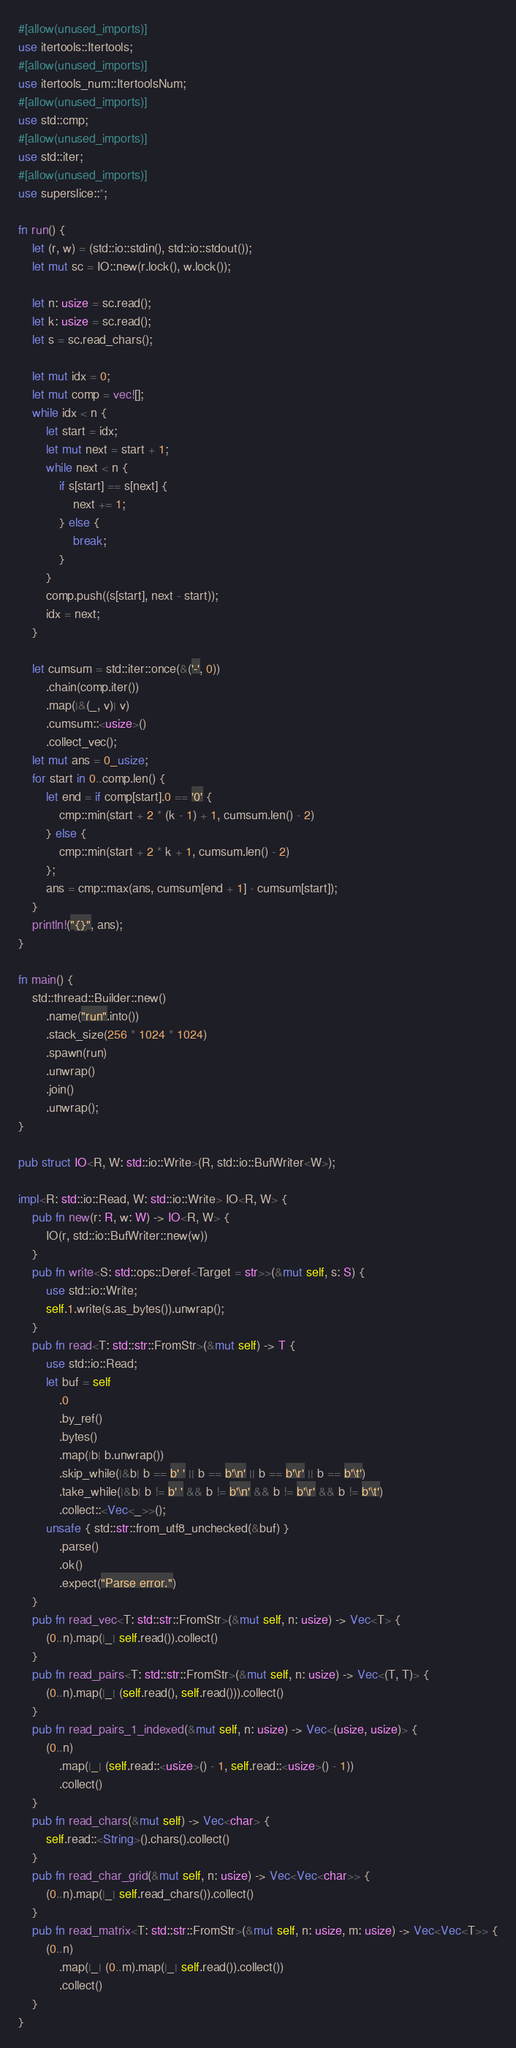<code> <loc_0><loc_0><loc_500><loc_500><_Rust_>#[allow(unused_imports)]
use itertools::Itertools;
#[allow(unused_imports)]
use itertools_num::ItertoolsNum;
#[allow(unused_imports)]
use std::cmp;
#[allow(unused_imports)]
use std::iter;
#[allow(unused_imports)]
use superslice::*;

fn run() {
    let (r, w) = (std::io::stdin(), std::io::stdout());
    let mut sc = IO::new(r.lock(), w.lock());

    let n: usize = sc.read();
    let k: usize = sc.read();
    let s = sc.read_chars();

    let mut idx = 0;
    let mut comp = vec![];
    while idx < n {
        let start = idx;
        let mut next = start + 1;
        while next < n {
            if s[start] == s[next] {
                next += 1;
            } else {
                break;
            }
        }
        comp.push((s[start], next - start));
        idx = next;
    }

    let cumsum = std::iter::once(&('-', 0))
        .chain(comp.iter())
        .map(|&(_, v)| v)
        .cumsum::<usize>()
        .collect_vec();
    let mut ans = 0_usize;
    for start in 0..comp.len() {
        let end = if comp[start].0 == '0' {
            cmp::min(start + 2 * (k - 1) + 1, cumsum.len() - 2)
        } else {
            cmp::min(start + 2 * k + 1, cumsum.len() - 2)
        };
        ans = cmp::max(ans, cumsum[end + 1] - cumsum[start]);
    }
    println!("{}", ans);
}

fn main() {
    std::thread::Builder::new()
        .name("run".into())
        .stack_size(256 * 1024 * 1024)
        .spawn(run)
        .unwrap()
        .join()
        .unwrap();
}

pub struct IO<R, W: std::io::Write>(R, std::io::BufWriter<W>);

impl<R: std::io::Read, W: std::io::Write> IO<R, W> {
    pub fn new(r: R, w: W) -> IO<R, W> {
        IO(r, std::io::BufWriter::new(w))
    }
    pub fn write<S: std::ops::Deref<Target = str>>(&mut self, s: S) {
        use std::io::Write;
        self.1.write(s.as_bytes()).unwrap();
    }
    pub fn read<T: std::str::FromStr>(&mut self) -> T {
        use std::io::Read;
        let buf = self
            .0
            .by_ref()
            .bytes()
            .map(|b| b.unwrap())
            .skip_while(|&b| b == b' ' || b == b'\n' || b == b'\r' || b == b'\t')
            .take_while(|&b| b != b' ' && b != b'\n' && b != b'\r' && b != b'\t')
            .collect::<Vec<_>>();
        unsafe { std::str::from_utf8_unchecked(&buf) }
            .parse()
            .ok()
            .expect("Parse error.")
    }
    pub fn read_vec<T: std::str::FromStr>(&mut self, n: usize) -> Vec<T> {
        (0..n).map(|_| self.read()).collect()
    }
    pub fn read_pairs<T: std::str::FromStr>(&mut self, n: usize) -> Vec<(T, T)> {
        (0..n).map(|_| (self.read(), self.read())).collect()
    }
    pub fn read_pairs_1_indexed(&mut self, n: usize) -> Vec<(usize, usize)> {
        (0..n)
            .map(|_| (self.read::<usize>() - 1, self.read::<usize>() - 1))
            .collect()
    }
    pub fn read_chars(&mut self) -> Vec<char> {
        self.read::<String>().chars().collect()
    }
    pub fn read_char_grid(&mut self, n: usize) -> Vec<Vec<char>> {
        (0..n).map(|_| self.read_chars()).collect()
    }
    pub fn read_matrix<T: std::str::FromStr>(&mut self, n: usize, m: usize) -> Vec<Vec<T>> {
        (0..n)
            .map(|_| (0..m).map(|_| self.read()).collect())
            .collect()
    }
}
</code> 